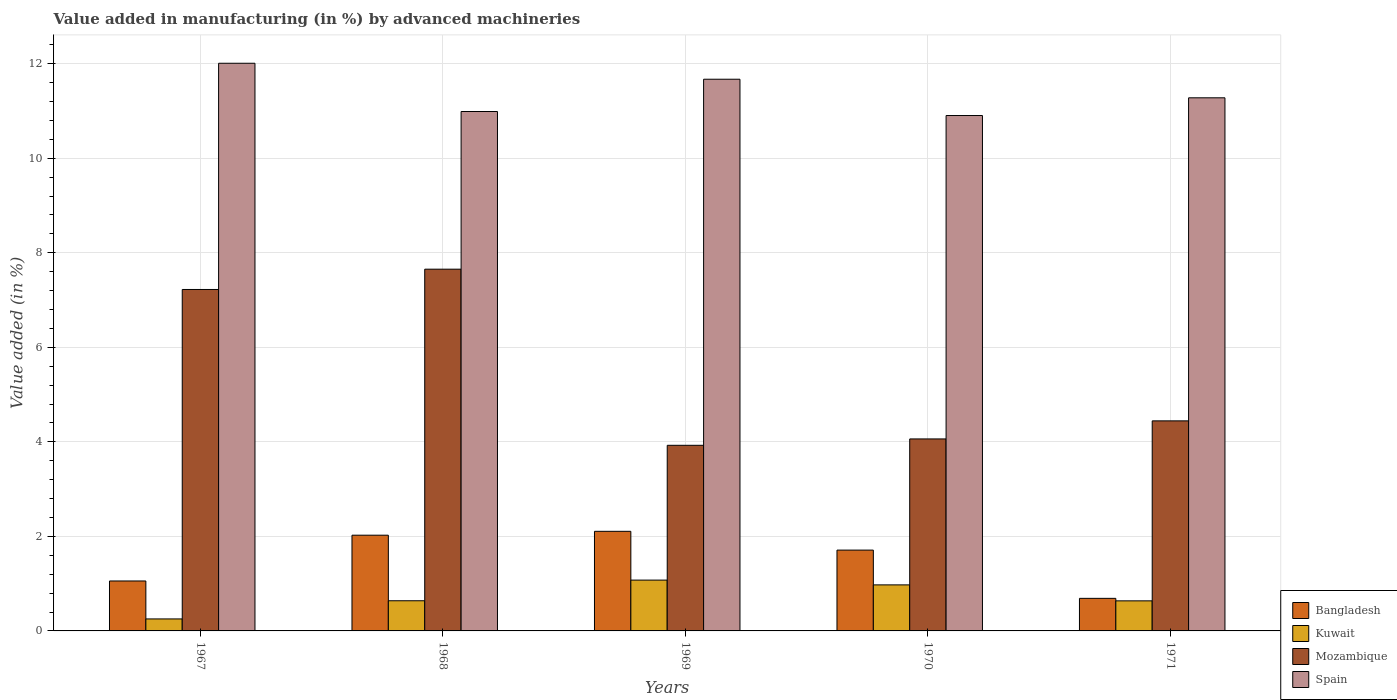How many groups of bars are there?
Your answer should be very brief. 5. Are the number of bars per tick equal to the number of legend labels?
Your response must be concise. Yes. Are the number of bars on each tick of the X-axis equal?
Your answer should be compact. Yes. How many bars are there on the 5th tick from the left?
Your answer should be compact. 4. How many bars are there on the 1st tick from the right?
Your answer should be compact. 4. What is the label of the 3rd group of bars from the left?
Ensure brevity in your answer.  1969. What is the percentage of value added in manufacturing by advanced machineries in Mozambique in 1970?
Your answer should be compact. 4.06. Across all years, what is the maximum percentage of value added in manufacturing by advanced machineries in Kuwait?
Your answer should be very brief. 1.08. Across all years, what is the minimum percentage of value added in manufacturing by advanced machineries in Spain?
Offer a very short reply. 10.9. In which year was the percentage of value added in manufacturing by advanced machineries in Mozambique maximum?
Give a very brief answer. 1968. In which year was the percentage of value added in manufacturing by advanced machineries in Kuwait minimum?
Your answer should be compact. 1967. What is the total percentage of value added in manufacturing by advanced machineries in Mozambique in the graph?
Offer a very short reply. 27.31. What is the difference between the percentage of value added in manufacturing by advanced machineries in Kuwait in 1968 and that in 1971?
Your answer should be very brief. 0. What is the difference between the percentage of value added in manufacturing by advanced machineries in Spain in 1970 and the percentage of value added in manufacturing by advanced machineries in Mozambique in 1967?
Give a very brief answer. 3.68. What is the average percentage of value added in manufacturing by advanced machineries in Spain per year?
Your answer should be very brief. 11.37. In the year 1967, what is the difference between the percentage of value added in manufacturing by advanced machineries in Mozambique and percentage of value added in manufacturing by advanced machineries in Kuwait?
Provide a short and direct response. 6.97. What is the ratio of the percentage of value added in manufacturing by advanced machineries in Spain in 1968 to that in 1969?
Your response must be concise. 0.94. Is the difference between the percentage of value added in manufacturing by advanced machineries in Mozambique in 1967 and 1970 greater than the difference between the percentage of value added in manufacturing by advanced machineries in Kuwait in 1967 and 1970?
Your response must be concise. Yes. What is the difference between the highest and the second highest percentage of value added in manufacturing by advanced machineries in Mozambique?
Provide a succinct answer. 0.43. What is the difference between the highest and the lowest percentage of value added in manufacturing by advanced machineries in Mozambique?
Give a very brief answer. 3.73. Is the sum of the percentage of value added in manufacturing by advanced machineries in Mozambique in 1970 and 1971 greater than the maximum percentage of value added in manufacturing by advanced machineries in Kuwait across all years?
Offer a very short reply. Yes. What does the 2nd bar from the left in 1969 represents?
Ensure brevity in your answer.  Kuwait. What does the 2nd bar from the right in 1970 represents?
Your answer should be very brief. Mozambique. How many bars are there?
Provide a short and direct response. 20. Are all the bars in the graph horizontal?
Your answer should be compact. No. How many years are there in the graph?
Provide a short and direct response. 5. Does the graph contain grids?
Your answer should be very brief. Yes. Where does the legend appear in the graph?
Make the answer very short. Bottom right. How many legend labels are there?
Provide a succinct answer. 4. What is the title of the graph?
Your answer should be compact. Value added in manufacturing (in %) by advanced machineries. What is the label or title of the X-axis?
Provide a succinct answer. Years. What is the label or title of the Y-axis?
Your answer should be very brief. Value added (in %). What is the Value added (in %) of Bangladesh in 1967?
Your answer should be compact. 1.06. What is the Value added (in %) of Kuwait in 1967?
Offer a terse response. 0.25. What is the Value added (in %) in Mozambique in 1967?
Make the answer very short. 7.22. What is the Value added (in %) of Spain in 1967?
Provide a short and direct response. 12.01. What is the Value added (in %) in Bangladesh in 1968?
Give a very brief answer. 2.03. What is the Value added (in %) of Kuwait in 1968?
Provide a short and direct response. 0.64. What is the Value added (in %) in Mozambique in 1968?
Your answer should be very brief. 7.65. What is the Value added (in %) of Spain in 1968?
Make the answer very short. 10.99. What is the Value added (in %) in Bangladesh in 1969?
Provide a short and direct response. 2.11. What is the Value added (in %) in Kuwait in 1969?
Keep it short and to the point. 1.08. What is the Value added (in %) in Mozambique in 1969?
Ensure brevity in your answer.  3.93. What is the Value added (in %) in Spain in 1969?
Keep it short and to the point. 11.67. What is the Value added (in %) in Bangladesh in 1970?
Your answer should be compact. 1.71. What is the Value added (in %) in Kuwait in 1970?
Your answer should be very brief. 0.97. What is the Value added (in %) of Mozambique in 1970?
Give a very brief answer. 4.06. What is the Value added (in %) in Spain in 1970?
Your answer should be very brief. 10.9. What is the Value added (in %) in Bangladesh in 1971?
Make the answer very short. 0.69. What is the Value added (in %) of Kuwait in 1971?
Offer a very short reply. 0.64. What is the Value added (in %) in Mozambique in 1971?
Your answer should be compact. 4.44. What is the Value added (in %) in Spain in 1971?
Provide a succinct answer. 11.28. Across all years, what is the maximum Value added (in %) in Bangladesh?
Make the answer very short. 2.11. Across all years, what is the maximum Value added (in %) in Kuwait?
Provide a short and direct response. 1.08. Across all years, what is the maximum Value added (in %) in Mozambique?
Ensure brevity in your answer.  7.65. Across all years, what is the maximum Value added (in %) of Spain?
Make the answer very short. 12.01. Across all years, what is the minimum Value added (in %) of Bangladesh?
Give a very brief answer. 0.69. Across all years, what is the minimum Value added (in %) in Kuwait?
Provide a succinct answer. 0.25. Across all years, what is the minimum Value added (in %) in Mozambique?
Make the answer very short. 3.93. Across all years, what is the minimum Value added (in %) of Spain?
Keep it short and to the point. 10.9. What is the total Value added (in %) in Bangladesh in the graph?
Your answer should be very brief. 7.59. What is the total Value added (in %) in Kuwait in the graph?
Keep it short and to the point. 3.58. What is the total Value added (in %) of Mozambique in the graph?
Give a very brief answer. 27.31. What is the total Value added (in %) in Spain in the graph?
Your response must be concise. 56.85. What is the difference between the Value added (in %) of Bangladesh in 1967 and that in 1968?
Your answer should be compact. -0.97. What is the difference between the Value added (in %) of Kuwait in 1967 and that in 1968?
Your answer should be very brief. -0.38. What is the difference between the Value added (in %) of Mozambique in 1967 and that in 1968?
Ensure brevity in your answer.  -0.43. What is the difference between the Value added (in %) of Spain in 1967 and that in 1968?
Give a very brief answer. 1.02. What is the difference between the Value added (in %) in Bangladesh in 1967 and that in 1969?
Give a very brief answer. -1.05. What is the difference between the Value added (in %) of Kuwait in 1967 and that in 1969?
Offer a very short reply. -0.82. What is the difference between the Value added (in %) of Mozambique in 1967 and that in 1969?
Provide a short and direct response. 3.3. What is the difference between the Value added (in %) of Spain in 1967 and that in 1969?
Provide a succinct answer. 0.34. What is the difference between the Value added (in %) of Bangladesh in 1967 and that in 1970?
Your answer should be very brief. -0.65. What is the difference between the Value added (in %) in Kuwait in 1967 and that in 1970?
Make the answer very short. -0.72. What is the difference between the Value added (in %) in Mozambique in 1967 and that in 1970?
Your response must be concise. 3.16. What is the difference between the Value added (in %) in Spain in 1967 and that in 1970?
Ensure brevity in your answer.  1.11. What is the difference between the Value added (in %) of Bangladesh in 1967 and that in 1971?
Your answer should be very brief. 0.37. What is the difference between the Value added (in %) of Kuwait in 1967 and that in 1971?
Make the answer very short. -0.38. What is the difference between the Value added (in %) in Mozambique in 1967 and that in 1971?
Give a very brief answer. 2.78. What is the difference between the Value added (in %) of Spain in 1967 and that in 1971?
Your answer should be compact. 0.73. What is the difference between the Value added (in %) of Bangladesh in 1968 and that in 1969?
Your answer should be compact. -0.08. What is the difference between the Value added (in %) of Kuwait in 1968 and that in 1969?
Offer a terse response. -0.44. What is the difference between the Value added (in %) of Mozambique in 1968 and that in 1969?
Your answer should be compact. 3.73. What is the difference between the Value added (in %) of Spain in 1968 and that in 1969?
Offer a terse response. -0.68. What is the difference between the Value added (in %) of Bangladesh in 1968 and that in 1970?
Ensure brevity in your answer.  0.32. What is the difference between the Value added (in %) of Kuwait in 1968 and that in 1970?
Offer a very short reply. -0.34. What is the difference between the Value added (in %) in Mozambique in 1968 and that in 1970?
Your answer should be compact. 3.59. What is the difference between the Value added (in %) in Spain in 1968 and that in 1970?
Provide a short and direct response. 0.09. What is the difference between the Value added (in %) in Bangladesh in 1968 and that in 1971?
Make the answer very short. 1.34. What is the difference between the Value added (in %) of Kuwait in 1968 and that in 1971?
Provide a short and direct response. 0. What is the difference between the Value added (in %) in Mozambique in 1968 and that in 1971?
Give a very brief answer. 3.21. What is the difference between the Value added (in %) in Spain in 1968 and that in 1971?
Offer a terse response. -0.29. What is the difference between the Value added (in %) of Bangladesh in 1969 and that in 1970?
Keep it short and to the point. 0.4. What is the difference between the Value added (in %) in Kuwait in 1969 and that in 1970?
Keep it short and to the point. 0.1. What is the difference between the Value added (in %) of Mozambique in 1969 and that in 1970?
Offer a very short reply. -0.14. What is the difference between the Value added (in %) in Spain in 1969 and that in 1970?
Your response must be concise. 0.77. What is the difference between the Value added (in %) in Bangladesh in 1969 and that in 1971?
Make the answer very short. 1.42. What is the difference between the Value added (in %) of Kuwait in 1969 and that in 1971?
Provide a succinct answer. 0.44. What is the difference between the Value added (in %) in Mozambique in 1969 and that in 1971?
Offer a very short reply. -0.52. What is the difference between the Value added (in %) of Spain in 1969 and that in 1971?
Offer a terse response. 0.39. What is the difference between the Value added (in %) of Bangladesh in 1970 and that in 1971?
Ensure brevity in your answer.  1.02. What is the difference between the Value added (in %) in Kuwait in 1970 and that in 1971?
Keep it short and to the point. 0.34. What is the difference between the Value added (in %) in Mozambique in 1970 and that in 1971?
Offer a very short reply. -0.38. What is the difference between the Value added (in %) of Spain in 1970 and that in 1971?
Make the answer very short. -0.37. What is the difference between the Value added (in %) of Bangladesh in 1967 and the Value added (in %) of Kuwait in 1968?
Offer a very short reply. 0.42. What is the difference between the Value added (in %) in Bangladesh in 1967 and the Value added (in %) in Mozambique in 1968?
Your response must be concise. -6.6. What is the difference between the Value added (in %) of Bangladesh in 1967 and the Value added (in %) of Spain in 1968?
Make the answer very short. -9.93. What is the difference between the Value added (in %) of Kuwait in 1967 and the Value added (in %) of Mozambique in 1968?
Your answer should be compact. -7.4. What is the difference between the Value added (in %) in Kuwait in 1967 and the Value added (in %) in Spain in 1968?
Provide a short and direct response. -10.73. What is the difference between the Value added (in %) of Mozambique in 1967 and the Value added (in %) of Spain in 1968?
Offer a terse response. -3.77. What is the difference between the Value added (in %) of Bangladesh in 1967 and the Value added (in %) of Kuwait in 1969?
Keep it short and to the point. -0.02. What is the difference between the Value added (in %) of Bangladesh in 1967 and the Value added (in %) of Mozambique in 1969?
Provide a short and direct response. -2.87. What is the difference between the Value added (in %) in Bangladesh in 1967 and the Value added (in %) in Spain in 1969?
Your response must be concise. -10.62. What is the difference between the Value added (in %) in Kuwait in 1967 and the Value added (in %) in Mozambique in 1969?
Provide a succinct answer. -3.67. What is the difference between the Value added (in %) of Kuwait in 1967 and the Value added (in %) of Spain in 1969?
Give a very brief answer. -11.42. What is the difference between the Value added (in %) in Mozambique in 1967 and the Value added (in %) in Spain in 1969?
Your answer should be compact. -4.45. What is the difference between the Value added (in %) of Bangladesh in 1967 and the Value added (in %) of Kuwait in 1970?
Offer a terse response. 0.08. What is the difference between the Value added (in %) in Bangladesh in 1967 and the Value added (in %) in Mozambique in 1970?
Your answer should be compact. -3. What is the difference between the Value added (in %) of Bangladesh in 1967 and the Value added (in %) of Spain in 1970?
Keep it short and to the point. -9.85. What is the difference between the Value added (in %) in Kuwait in 1967 and the Value added (in %) in Mozambique in 1970?
Provide a short and direct response. -3.81. What is the difference between the Value added (in %) in Kuwait in 1967 and the Value added (in %) in Spain in 1970?
Your response must be concise. -10.65. What is the difference between the Value added (in %) of Mozambique in 1967 and the Value added (in %) of Spain in 1970?
Give a very brief answer. -3.68. What is the difference between the Value added (in %) of Bangladesh in 1967 and the Value added (in %) of Kuwait in 1971?
Your answer should be very brief. 0.42. What is the difference between the Value added (in %) in Bangladesh in 1967 and the Value added (in %) in Mozambique in 1971?
Offer a very short reply. -3.39. What is the difference between the Value added (in %) of Bangladesh in 1967 and the Value added (in %) of Spain in 1971?
Your answer should be compact. -10.22. What is the difference between the Value added (in %) of Kuwait in 1967 and the Value added (in %) of Mozambique in 1971?
Your answer should be very brief. -4.19. What is the difference between the Value added (in %) in Kuwait in 1967 and the Value added (in %) in Spain in 1971?
Offer a very short reply. -11.02. What is the difference between the Value added (in %) of Mozambique in 1967 and the Value added (in %) of Spain in 1971?
Ensure brevity in your answer.  -4.05. What is the difference between the Value added (in %) in Bangladesh in 1968 and the Value added (in %) in Kuwait in 1969?
Your response must be concise. 0.95. What is the difference between the Value added (in %) of Bangladesh in 1968 and the Value added (in %) of Mozambique in 1969?
Make the answer very short. -1.9. What is the difference between the Value added (in %) of Bangladesh in 1968 and the Value added (in %) of Spain in 1969?
Your answer should be very brief. -9.65. What is the difference between the Value added (in %) of Kuwait in 1968 and the Value added (in %) of Mozambique in 1969?
Offer a very short reply. -3.29. What is the difference between the Value added (in %) in Kuwait in 1968 and the Value added (in %) in Spain in 1969?
Ensure brevity in your answer.  -11.03. What is the difference between the Value added (in %) in Mozambique in 1968 and the Value added (in %) in Spain in 1969?
Your response must be concise. -4.02. What is the difference between the Value added (in %) of Bangladesh in 1968 and the Value added (in %) of Kuwait in 1970?
Your answer should be very brief. 1.05. What is the difference between the Value added (in %) in Bangladesh in 1968 and the Value added (in %) in Mozambique in 1970?
Provide a succinct answer. -2.04. What is the difference between the Value added (in %) of Bangladesh in 1968 and the Value added (in %) of Spain in 1970?
Give a very brief answer. -8.88. What is the difference between the Value added (in %) of Kuwait in 1968 and the Value added (in %) of Mozambique in 1970?
Make the answer very short. -3.42. What is the difference between the Value added (in %) of Kuwait in 1968 and the Value added (in %) of Spain in 1970?
Provide a succinct answer. -10.27. What is the difference between the Value added (in %) in Mozambique in 1968 and the Value added (in %) in Spain in 1970?
Offer a very short reply. -3.25. What is the difference between the Value added (in %) of Bangladesh in 1968 and the Value added (in %) of Kuwait in 1971?
Your answer should be compact. 1.39. What is the difference between the Value added (in %) of Bangladesh in 1968 and the Value added (in %) of Mozambique in 1971?
Offer a very short reply. -2.42. What is the difference between the Value added (in %) in Bangladesh in 1968 and the Value added (in %) in Spain in 1971?
Your response must be concise. -9.25. What is the difference between the Value added (in %) in Kuwait in 1968 and the Value added (in %) in Mozambique in 1971?
Give a very brief answer. -3.81. What is the difference between the Value added (in %) of Kuwait in 1968 and the Value added (in %) of Spain in 1971?
Your answer should be very brief. -10.64. What is the difference between the Value added (in %) of Mozambique in 1968 and the Value added (in %) of Spain in 1971?
Give a very brief answer. -3.63. What is the difference between the Value added (in %) in Bangladesh in 1969 and the Value added (in %) in Kuwait in 1970?
Provide a succinct answer. 1.13. What is the difference between the Value added (in %) of Bangladesh in 1969 and the Value added (in %) of Mozambique in 1970?
Ensure brevity in your answer.  -1.95. What is the difference between the Value added (in %) of Bangladesh in 1969 and the Value added (in %) of Spain in 1970?
Provide a succinct answer. -8.8. What is the difference between the Value added (in %) in Kuwait in 1969 and the Value added (in %) in Mozambique in 1970?
Offer a very short reply. -2.99. What is the difference between the Value added (in %) in Kuwait in 1969 and the Value added (in %) in Spain in 1970?
Offer a very short reply. -9.83. What is the difference between the Value added (in %) in Mozambique in 1969 and the Value added (in %) in Spain in 1970?
Provide a succinct answer. -6.98. What is the difference between the Value added (in %) in Bangladesh in 1969 and the Value added (in %) in Kuwait in 1971?
Make the answer very short. 1.47. What is the difference between the Value added (in %) of Bangladesh in 1969 and the Value added (in %) of Mozambique in 1971?
Offer a terse response. -2.34. What is the difference between the Value added (in %) of Bangladesh in 1969 and the Value added (in %) of Spain in 1971?
Provide a succinct answer. -9.17. What is the difference between the Value added (in %) of Kuwait in 1969 and the Value added (in %) of Mozambique in 1971?
Ensure brevity in your answer.  -3.37. What is the difference between the Value added (in %) of Kuwait in 1969 and the Value added (in %) of Spain in 1971?
Your answer should be compact. -10.2. What is the difference between the Value added (in %) of Mozambique in 1969 and the Value added (in %) of Spain in 1971?
Your response must be concise. -7.35. What is the difference between the Value added (in %) of Bangladesh in 1970 and the Value added (in %) of Kuwait in 1971?
Provide a short and direct response. 1.07. What is the difference between the Value added (in %) in Bangladesh in 1970 and the Value added (in %) in Mozambique in 1971?
Make the answer very short. -2.73. What is the difference between the Value added (in %) of Bangladesh in 1970 and the Value added (in %) of Spain in 1971?
Offer a terse response. -9.57. What is the difference between the Value added (in %) in Kuwait in 1970 and the Value added (in %) in Mozambique in 1971?
Provide a short and direct response. -3.47. What is the difference between the Value added (in %) in Kuwait in 1970 and the Value added (in %) in Spain in 1971?
Your response must be concise. -10.3. What is the difference between the Value added (in %) in Mozambique in 1970 and the Value added (in %) in Spain in 1971?
Ensure brevity in your answer.  -7.22. What is the average Value added (in %) in Bangladesh per year?
Keep it short and to the point. 1.52. What is the average Value added (in %) of Kuwait per year?
Provide a succinct answer. 0.72. What is the average Value added (in %) in Mozambique per year?
Make the answer very short. 5.46. What is the average Value added (in %) of Spain per year?
Your answer should be very brief. 11.37. In the year 1967, what is the difference between the Value added (in %) in Bangladesh and Value added (in %) in Kuwait?
Keep it short and to the point. 0.8. In the year 1967, what is the difference between the Value added (in %) of Bangladesh and Value added (in %) of Mozambique?
Offer a very short reply. -6.17. In the year 1967, what is the difference between the Value added (in %) of Bangladesh and Value added (in %) of Spain?
Ensure brevity in your answer.  -10.95. In the year 1967, what is the difference between the Value added (in %) of Kuwait and Value added (in %) of Mozambique?
Ensure brevity in your answer.  -6.97. In the year 1967, what is the difference between the Value added (in %) of Kuwait and Value added (in %) of Spain?
Provide a short and direct response. -11.76. In the year 1967, what is the difference between the Value added (in %) of Mozambique and Value added (in %) of Spain?
Make the answer very short. -4.79. In the year 1968, what is the difference between the Value added (in %) in Bangladesh and Value added (in %) in Kuwait?
Offer a terse response. 1.39. In the year 1968, what is the difference between the Value added (in %) in Bangladesh and Value added (in %) in Mozambique?
Your answer should be compact. -5.63. In the year 1968, what is the difference between the Value added (in %) in Bangladesh and Value added (in %) in Spain?
Offer a very short reply. -8.96. In the year 1968, what is the difference between the Value added (in %) in Kuwait and Value added (in %) in Mozambique?
Your answer should be very brief. -7.01. In the year 1968, what is the difference between the Value added (in %) of Kuwait and Value added (in %) of Spain?
Offer a terse response. -10.35. In the year 1968, what is the difference between the Value added (in %) of Mozambique and Value added (in %) of Spain?
Your response must be concise. -3.34. In the year 1969, what is the difference between the Value added (in %) in Bangladesh and Value added (in %) in Kuwait?
Your answer should be compact. 1.03. In the year 1969, what is the difference between the Value added (in %) in Bangladesh and Value added (in %) in Mozambique?
Give a very brief answer. -1.82. In the year 1969, what is the difference between the Value added (in %) of Bangladesh and Value added (in %) of Spain?
Your response must be concise. -9.56. In the year 1969, what is the difference between the Value added (in %) of Kuwait and Value added (in %) of Mozambique?
Give a very brief answer. -2.85. In the year 1969, what is the difference between the Value added (in %) in Kuwait and Value added (in %) in Spain?
Provide a short and direct response. -10.6. In the year 1969, what is the difference between the Value added (in %) in Mozambique and Value added (in %) in Spain?
Provide a short and direct response. -7.75. In the year 1970, what is the difference between the Value added (in %) in Bangladesh and Value added (in %) in Kuwait?
Offer a terse response. 0.74. In the year 1970, what is the difference between the Value added (in %) of Bangladesh and Value added (in %) of Mozambique?
Your response must be concise. -2.35. In the year 1970, what is the difference between the Value added (in %) in Bangladesh and Value added (in %) in Spain?
Keep it short and to the point. -9.19. In the year 1970, what is the difference between the Value added (in %) of Kuwait and Value added (in %) of Mozambique?
Your response must be concise. -3.09. In the year 1970, what is the difference between the Value added (in %) in Kuwait and Value added (in %) in Spain?
Provide a short and direct response. -9.93. In the year 1970, what is the difference between the Value added (in %) of Mozambique and Value added (in %) of Spain?
Provide a short and direct response. -6.84. In the year 1971, what is the difference between the Value added (in %) of Bangladesh and Value added (in %) of Kuwait?
Provide a short and direct response. 0.05. In the year 1971, what is the difference between the Value added (in %) of Bangladesh and Value added (in %) of Mozambique?
Make the answer very short. -3.75. In the year 1971, what is the difference between the Value added (in %) in Bangladesh and Value added (in %) in Spain?
Make the answer very short. -10.59. In the year 1971, what is the difference between the Value added (in %) in Kuwait and Value added (in %) in Mozambique?
Provide a succinct answer. -3.81. In the year 1971, what is the difference between the Value added (in %) of Kuwait and Value added (in %) of Spain?
Your answer should be very brief. -10.64. In the year 1971, what is the difference between the Value added (in %) of Mozambique and Value added (in %) of Spain?
Your answer should be very brief. -6.83. What is the ratio of the Value added (in %) of Bangladesh in 1967 to that in 1968?
Give a very brief answer. 0.52. What is the ratio of the Value added (in %) of Kuwait in 1967 to that in 1968?
Your response must be concise. 0.4. What is the ratio of the Value added (in %) in Mozambique in 1967 to that in 1968?
Your answer should be compact. 0.94. What is the ratio of the Value added (in %) of Spain in 1967 to that in 1968?
Keep it short and to the point. 1.09. What is the ratio of the Value added (in %) in Bangladesh in 1967 to that in 1969?
Your answer should be very brief. 0.5. What is the ratio of the Value added (in %) in Kuwait in 1967 to that in 1969?
Your answer should be very brief. 0.24. What is the ratio of the Value added (in %) of Mozambique in 1967 to that in 1969?
Provide a succinct answer. 1.84. What is the ratio of the Value added (in %) in Spain in 1967 to that in 1969?
Your answer should be compact. 1.03. What is the ratio of the Value added (in %) of Bangladesh in 1967 to that in 1970?
Offer a very short reply. 0.62. What is the ratio of the Value added (in %) in Kuwait in 1967 to that in 1970?
Ensure brevity in your answer.  0.26. What is the ratio of the Value added (in %) in Mozambique in 1967 to that in 1970?
Offer a terse response. 1.78. What is the ratio of the Value added (in %) in Spain in 1967 to that in 1970?
Ensure brevity in your answer.  1.1. What is the ratio of the Value added (in %) of Bangladesh in 1967 to that in 1971?
Your answer should be compact. 1.53. What is the ratio of the Value added (in %) in Kuwait in 1967 to that in 1971?
Offer a terse response. 0.4. What is the ratio of the Value added (in %) of Mozambique in 1967 to that in 1971?
Give a very brief answer. 1.63. What is the ratio of the Value added (in %) of Spain in 1967 to that in 1971?
Your response must be concise. 1.06. What is the ratio of the Value added (in %) of Bangladesh in 1968 to that in 1969?
Offer a terse response. 0.96. What is the ratio of the Value added (in %) in Kuwait in 1968 to that in 1969?
Your response must be concise. 0.59. What is the ratio of the Value added (in %) in Mozambique in 1968 to that in 1969?
Ensure brevity in your answer.  1.95. What is the ratio of the Value added (in %) in Spain in 1968 to that in 1969?
Offer a very short reply. 0.94. What is the ratio of the Value added (in %) of Bangladesh in 1968 to that in 1970?
Provide a short and direct response. 1.18. What is the ratio of the Value added (in %) in Kuwait in 1968 to that in 1970?
Offer a terse response. 0.66. What is the ratio of the Value added (in %) in Mozambique in 1968 to that in 1970?
Keep it short and to the point. 1.88. What is the ratio of the Value added (in %) in Spain in 1968 to that in 1970?
Your answer should be very brief. 1.01. What is the ratio of the Value added (in %) in Bangladesh in 1968 to that in 1971?
Make the answer very short. 2.94. What is the ratio of the Value added (in %) of Mozambique in 1968 to that in 1971?
Offer a very short reply. 1.72. What is the ratio of the Value added (in %) in Spain in 1968 to that in 1971?
Your answer should be very brief. 0.97. What is the ratio of the Value added (in %) in Bangladesh in 1969 to that in 1970?
Keep it short and to the point. 1.23. What is the ratio of the Value added (in %) in Kuwait in 1969 to that in 1970?
Your response must be concise. 1.1. What is the ratio of the Value added (in %) in Mozambique in 1969 to that in 1970?
Keep it short and to the point. 0.97. What is the ratio of the Value added (in %) in Spain in 1969 to that in 1970?
Provide a short and direct response. 1.07. What is the ratio of the Value added (in %) in Bangladesh in 1969 to that in 1971?
Offer a very short reply. 3.06. What is the ratio of the Value added (in %) of Kuwait in 1969 to that in 1971?
Provide a succinct answer. 1.69. What is the ratio of the Value added (in %) in Mozambique in 1969 to that in 1971?
Provide a succinct answer. 0.88. What is the ratio of the Value added (in %) in Spain in 1969 to that in 1971?
Your answer should be compact. 1.03. What is the ratio of the Value added (in %) of Bangladesh in 1970 to that in 1971?
Keep it short and to the point. 2.48. What is the ratio of the Value added (in %) in Kuwait in 1970 to that in 1971?
Offer a very short reply. 1.53. What is the ratio of the Value added (in %) in Mozambique in 1970 to that in 1971?
Provide a short and direct response. 0.91. What is the ratio of the Value added (in %) of Spain in 1970 to that in 1971?
Your response must be concise. 0.97. What is the difference between the highest and the second highest Value added (in %) of Bangladesh?
Offer a terse response. 0.08. What is the difference between the highest and the second highest Value added (in %) in Kuwait?
Your answer should be compact. 0.1. What is the difference between the highest and the second highest Value added (in %) in Mozambique?
Your response must be concise. 0.43. What is the difference between the highest and the second highest Value added (in %) in Spain?
Ensure brevity in your answer.  0.34. What is the difference between the highest and the lowest Value added (in %) of Bangladesh?
Make the answer very short. 1.42. What is the difference between the highest and the lowest Value added (in %) in Kuwait?
Give a very brief answer. 0.82. What is the difference between the highest and the lowest Value added (in %) in Mozambique?
Your response must be concise. 3.73. What is the difference between the highest and the lowest Value added (in %) of Spain?
Keep it short and to the point. 1.11. 